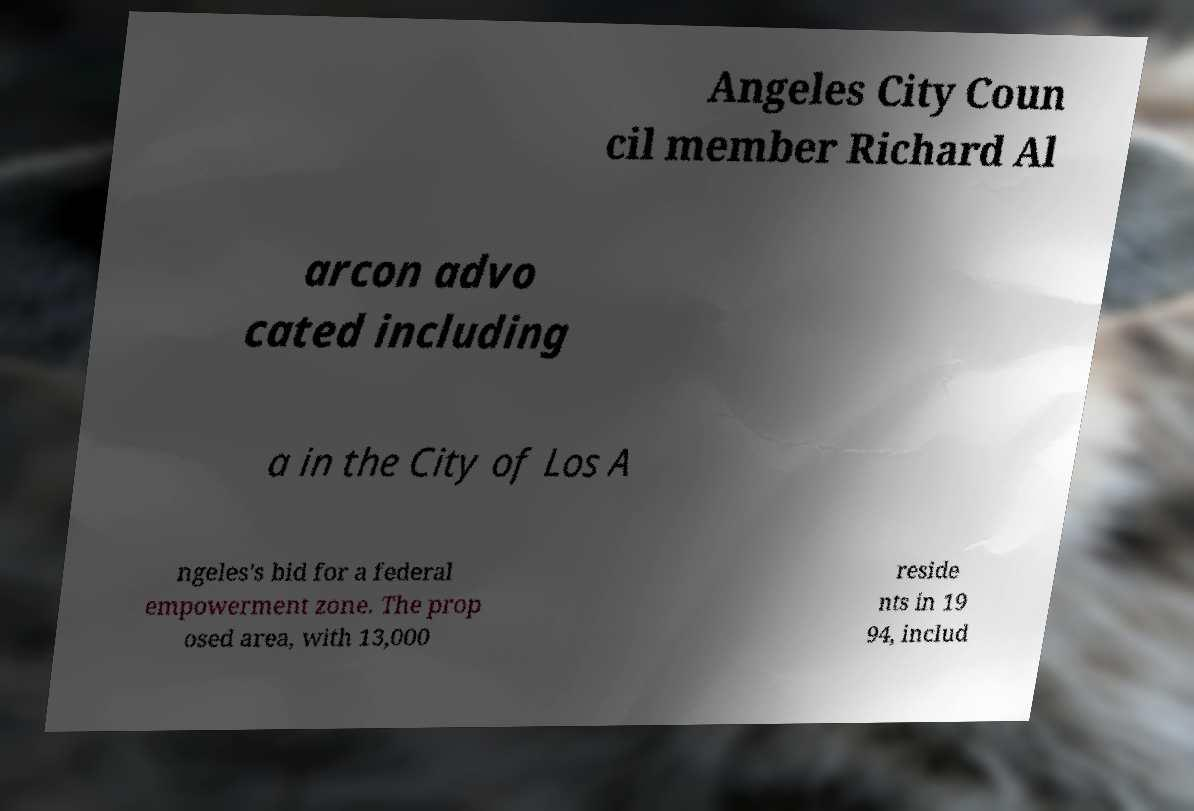For documentation purposes, I need the text within this image transcribed. Could you provide that? Angeles City Coun cil member Richard Al arcon advo cated including a in the City of Los A ngeles's bid for a federal empowerment zone. The prop osed area, with 13,000 reside nts in 19 94, includ 